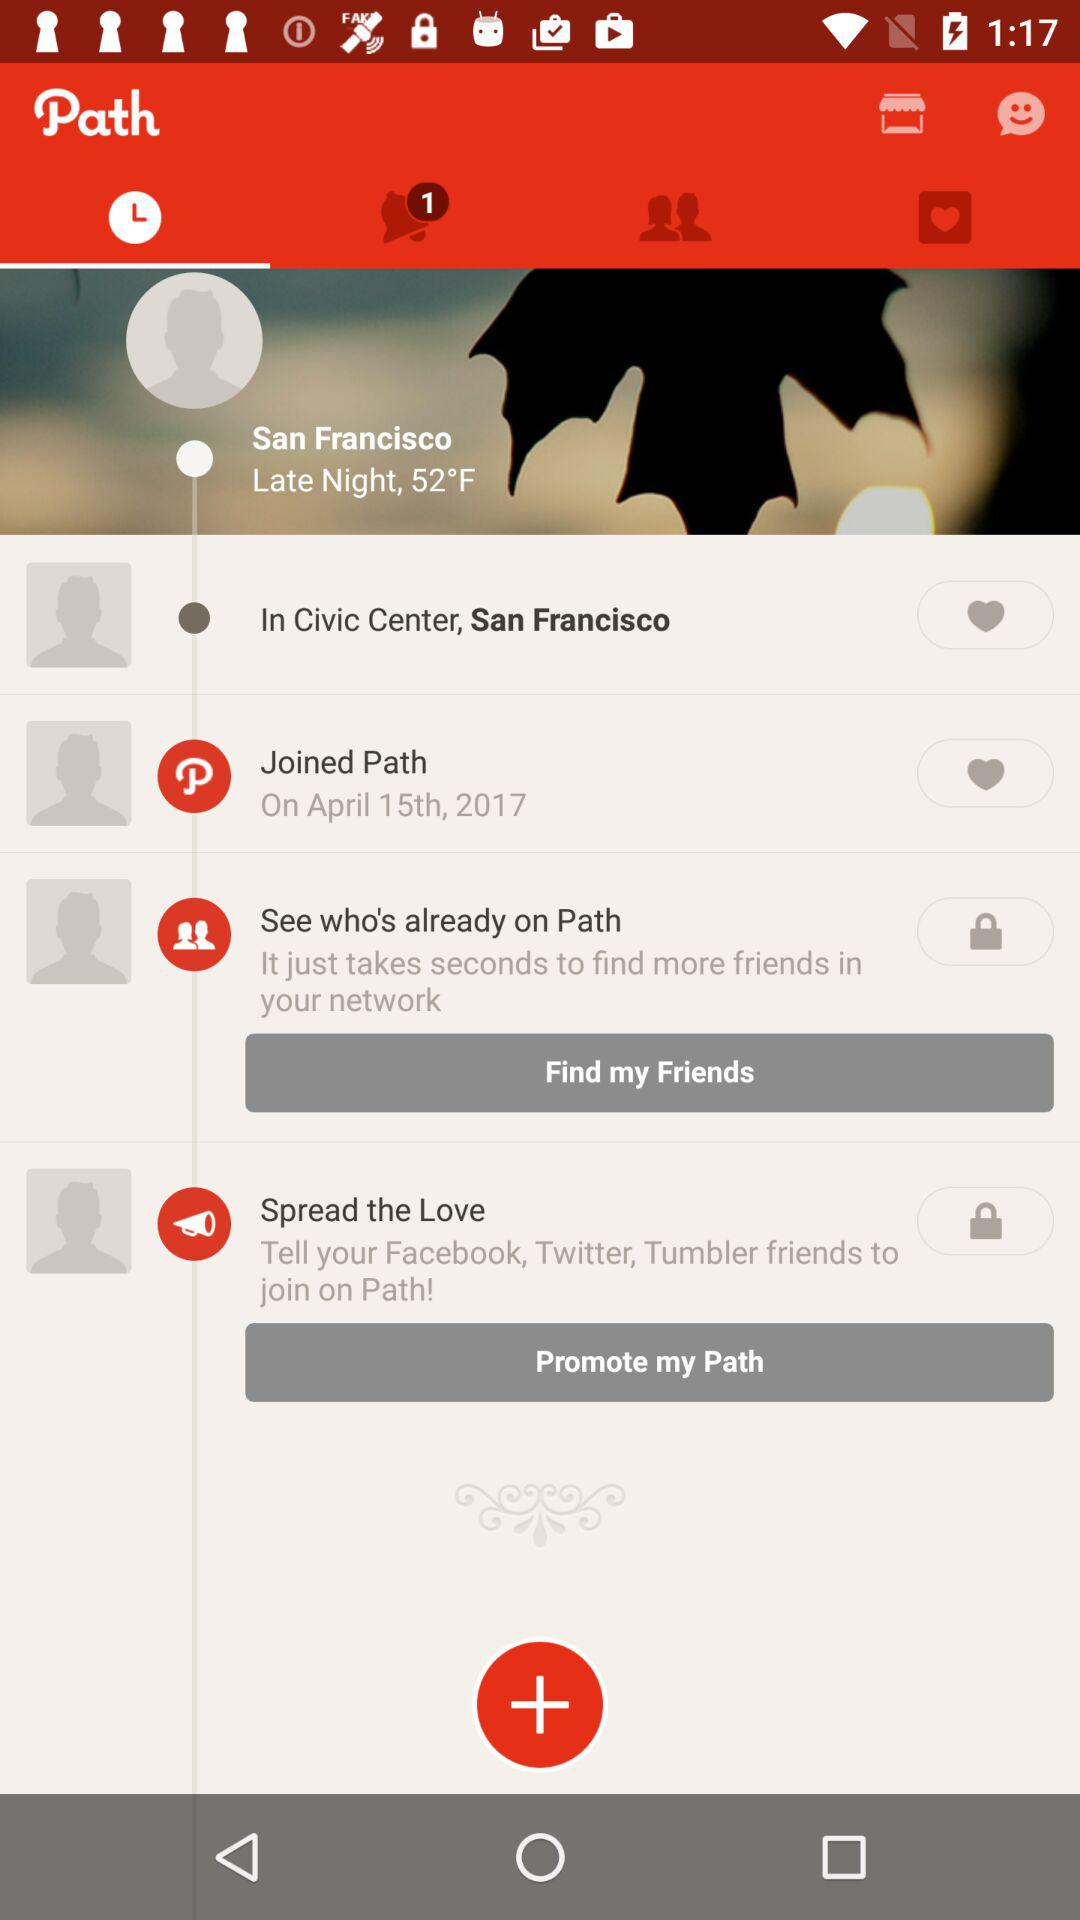On what date did the user join "Path"? The user joined "Path" on April 15, 2017. 